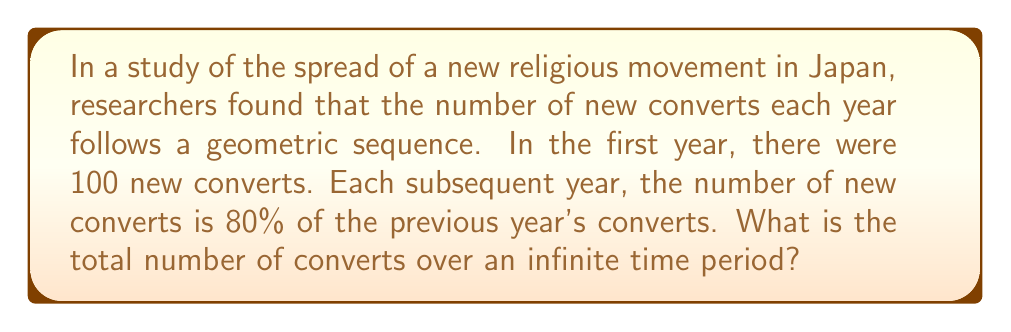Could you help me with this problem? Let's approach this step-by-step:

1) First, we identify the components of our geometric series:
   - Initial term, $a = 100$ (first year's converts)
   - Common ratio, $r = 0.8$ (each year is 80% of the previous)

2) The formula for the sum of an infinite geometric series is:

   $$S_{\infty} = \frac{a}{1-r}$$

   Where $S_{\infty}$ is the sum of the infinite series, $a$ is the first term, and $r$ is the common ratio.

3) This formula is valid when $|r| < 1$, which is true in our case as $0.8 < 1$.

4) Let's substitute our values:

   $$S_{\infty} = \frac{100}{1-0.8}$$

5) Simplify:
   $$S_{\infty} = \frac{100}{0.2}$$

6) Calculate:
   $$S_{\infty} = 500$$

Therefore, over an infinite time period, the total number of converts would be 500.
Answer: 500 converts 